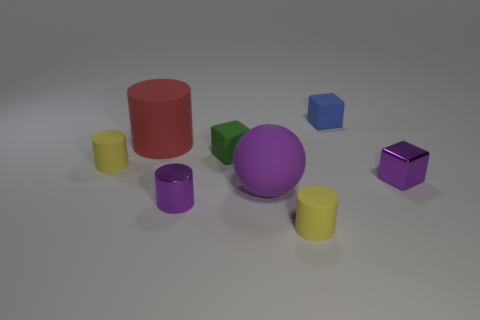How many gray objects are either rubber cylinders or big rubber things?
Provide a succinct answer. 0. How many blue matte cubes are there?
Provide a short and direct response. 1. What is the size of the metallic block behind the large purple matte sphere?
Make the answer very short. Small. Do the red cylinder and the green matte object have the same size?
Ensure brevity in your answer.  No. How many things are either purple shiny cylinders or metallic things left of the blue matte cube?
Make the answer very short. 1. What is the material of the small green object?
Offer a very short reply. Rubber. Are there any other things of the same color as the large ball?
Give a very brief answer. Yes. Does the tiny green rubber thing have the same shape as the purple matte thing?
Ensure brevity in your answer.  No. There is a yellow object left of the tiny thing in front of the small purple object in front of the purple metal cube; what is its size?
Your answer should be compact. Small. How many other objects are there of the same material as the purple sphere?
Your answer should be compact. 5. 